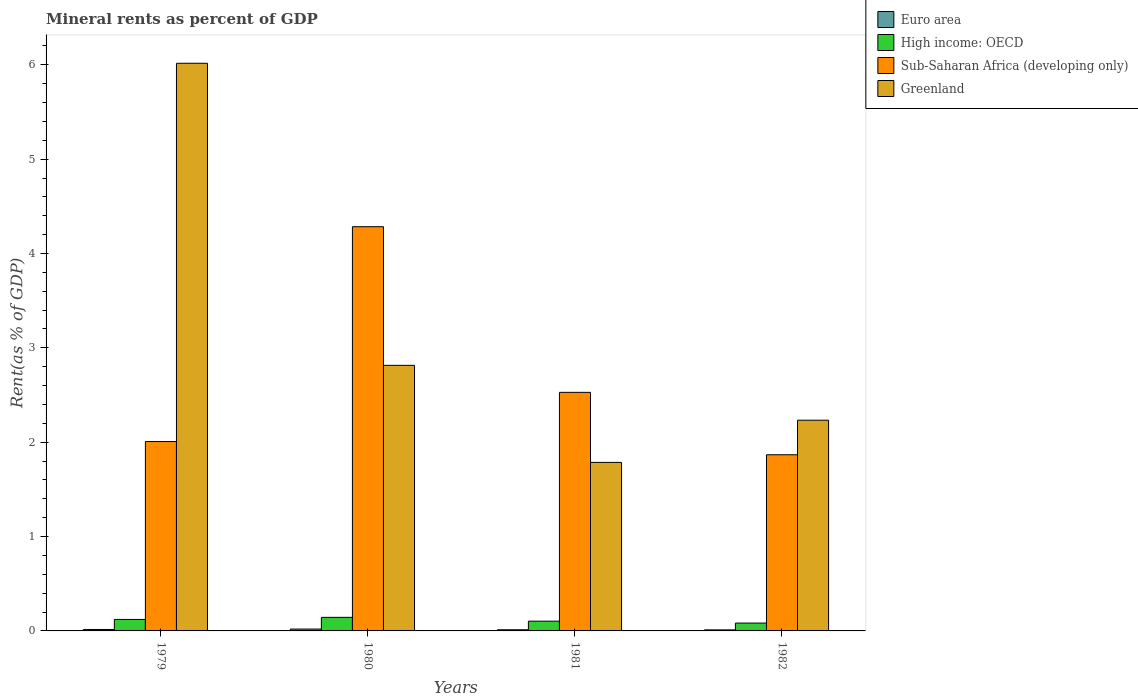How many different coloured bars are there?
Ensure brevity in your answer.  4. How many bars are there on the 1st tick from the left?
Give a very brief answer. 4. How many bars are there on the 1st tick from the right?
Your answer should be very brief. 4. What is the label of the 1st group of bars from the left?
Offer a very short reply. 1979. What is the mineral rent in Sub-Saharan Africa (developing only) in 1982?
Your response must be concise. 1.87. Across all years, what is the maximum mineral rent in Euro area?
Provide a succinct answer. 0.02. Across all years, what is the minimum mineral rent in Greenland?
Your response must be concise. 1.79. In which year was the mineral rent in Euro area minimum?
Your answer should be compact. 1982. What is the total mineral rent in Greenland in the graph?
Offer a very short reply. 12.85. What is the difference between the mineral rent in Greenland in 1979 and that in 1982?
Offer a terse response. 3.78. What is the difference between the mineral rent in Sub-Saharan Africa (developing only) in 1982 and the mineral rent in Euro area in 1980?
Your answer should be very brief. 1.85. What is the average mineral rent in Sub-Saharan Africa (developing only) per year?
Your response must be concise. 2.67. In the year 1980, what is the difference between the mineral rent in Euro area and mineral rent in Greenland?
Ensure brevity in your answer.  -2.8. What is the ratio of the mineral rent in High income: OECD in 1980 to that in 1981?
Your response must be concise. 1.39. Is the difference between the mineral rent in Euro area in 1979 and 1982 greater than the difference between the mineral rent in Greenland in 1979 and 1982?
Ensure brevity in your answer.  No. What is the difference between the highest and the second highest mineral rent in Euro area?
Offer a terse response. 0. What is the difference between the highest and the lowest mineral rent in Euro area?
Give a very brief answer. 0.01. In how many years, is the mineral rent in High income: OECD greater than the average mineral rent in High income: OECD taken over all years?
Your answer should be compact. 2. Is it the case that in every year, the sum of the mineral rent in Euro area and mineral rent in Sub-Saharan Africa (developing only) is greater than the sum of mineral rent in High income: OECD and mineral rent in Greenland?
Provide a short and direct response. No. What does the 3rd bar from the left in 1980 represents?
Give a very brief answer. Sub-Saharan Africa (developing only). What does the 1st bar from the right in 1981 represents?
Keep it short and to the point. Greenland. How many bars are there?
Your response must be concise. 16. How many years are there in the graph?
Offer a very short reply. 4. What is the difference between two consecutive major ticks on the Y-axis?
Make the answer very short. 1. Are the values on the major ticks of Y-axis written in scientific E-notation?
Your answer should be compact. No. Does the graph contain any zero values?
Your response must be concise. No. Does the graph contain grids?
Your answer should be compact. No. Where does the legend appear in the graph?
Ensure brevity in your answer.  Top right. How many legend labels are there?
Offer a terse response. 4. What is the title of the graph?
Your answer should be very brief. Mineral rents as percent of GDP. Does "Antigua and Barbuda" appear as one of the legend labels in the graph?
Offer a terse response. No. What is the label or title of the X-axis?
Your response must be concise. Years. What is the label or title of the Y-axis?
Keep it short and to the point. Rent(as % of GDP). What is the Rent(as % of GDP) of Euro area in 1979?
Your answer should be very brief. 0.02. What is the Rent(as % of GDP) in High income: OECD in 1979?
Ensure brevity in your answer.  0.12. What is the Rent(as % of GDP) of Sub-Saharan Africa (developing only) in 1979?
Your response must be concise. 2.01. What is the Rent(as % of GDP) of Greenland in 1979?
Offer a terse response. 6.02. What is the Rent(as % of GDP) of Euro area in 1980?
Your answer should be very brief. 0.02. What is the Rent(as % of GDP) in High income: OECD in 1980?
Ensure brevity in your answer.  0.14. What is the Rent(as % of GDP) in Sub-Saharan Africa (developing only) in 1980?
Provide a short and direct response. 4.28. What is the Rent(as % of GDP) of Greenland in 1980?
Offer a terse response. 2.81. What is the Rent(as % of GDP) of Euro area in 1981?
Offer a terse response. 0.01. What is the Rent(as % of GDP) of High income: OECD in 1981?
Provide a short and direct response. 0.1. What is the Rent(as % of GDP) of Sub-Saharan Africa (developing only) in 1981?
Your response must be concise. 2.53. What is the Rent(as % of GDP) of Greenland in 1981?
Make the answer very short. 1.79. What is the Rent(as % of GDP) in Euro area in 1982?
Offer a terse response. 0.01. What is the Rent(as % of GDP) in High income: OECD in 1982?
Keep it short and to the point. 0.08. What is the Rent(as % of GDP) of Sub-Saharan Africa (developing only) in 1982?
Your answer should be compact. 1.87. What is the Rent(as % of GDP) of Greenland in 1982?
Your answer should be very brief. 2.23. Across all years, what is the maximum Rent(as % of GDP) in Euro area?
Make the answer very short. 0.02. Across all years, what is the maximum Rent(as % of GDP) in High income: OECD?
Your answer should be compact. 0.14. Across all years, what is the maximum Rent(as % of GDP) of Sub-Saharan Africa (developing only)?
Offer a terse response. 4.28. Across all years, what is the maximum Rent(as % of GDP) in Greenland?
Provide a short and direct response. 6.02. Across all years, what is the minimum Rent(as % of GDP) in Euro area?
Provide a short and direct response. 0.01. Across all years, what is the minimum Rent(as % of GDP) in High income: OECD?
Provide a succinct answer. 0.08. Across all years, what is the minimum Rent(as % of GDP) in Sub-Saharan Africa (developing only)?
Offer a very short reply. 1.87. Across all years, what is the minimum Rent(as % of GDP) in Greenland?
Keep it short and to the point. 1.79. What is the total Rent(as % of GDP) of Euro area in the graph?
Your answer should be very brief. 0.06. What is the total Rent(as % of GDP) of High income: OECD in the graph?
Give a very brief answer. 0.45. What is the total Rent(as % of GDP) of Sub-Saharan Africa (developing only) in the graph?
Your answer should be very brief. 10.69. What is the total Rent(as % of GDP) in Greenland in the graph?
Your response must be concise. 12.85. What is the difference between the Rent(as % of GDP) in Euro area in 1979 and that in 1980?
Provide a short and direct response. -0. What is the difference between the Rent(as % of GDP) in High income: OECD in 1979 and that in 1980?
Your answer should be compact. -0.02. What is the difference between the Rent(as % of GDP) in Sub-Saharan Africa (developing only) in 1979 and that in 1980?
Provide a short and direct response. -2.28. What is the difference between the Rent(as % of GDP) in Greenland in 1979 and that in 1980?
Your response must be concise. 3.2. What is the difference between the Rent(as % of GDP) of Euro area in 1979 and that in 1981?
Make the answer very short. 0. What is the difference between the Rent(as % of GDP) of High income: OECD in 1979 and that in 1981?
Your response must be concise. 0.02. What is the difference between the Rent(as % of GDP) of Sub-Saharan Africa (developing only) in 1979 and that in 1981?
Make the answer very short. -0.52. What is the difference between the Rent(as % of GDP) in Greenland in 1979 and that in 1981?
Keep it short and to the point. 4.23. What is the difference between the Rent(as % of GDP) in Euro area in 1979 and that in 1982?
Ensure brevity in your answer.  0. What is the difference between the Rent(as % of GDP) in High income: OECD in 1979 and that in 1982?
Offer a very short reply. 0.04. What is the difference between the Rent(as % of GDP) in Sub-Saharan Africa (developing only) in 1979 and that in 1982?
Offer a terse response. 0.14. What is the difference between the Rent(as % of GDP) of Greenland in 1979 and that in 1982?
Provide a succinct answer. 3.78. What is the difference between the Rent(as % of GDP) in Euro area in 1980 and that in 1981?
Keep it short and to the point. 0.01. What is the difference between the Rent(as % of GDP) in High income: OECD in 1980 and that in 1981?
Make the answer very short. 0.04. What is the difference between the Rent(as % of GDP) of Sub-Saharan Africa (developing only) in 1980 and that in 1981?
Make the answer very short. 1.76. What is the difference between the Rent(as % of GDP) of Greenland in 1980 and that in 1981?
Your answer should be very brief. 1.03. What is the difference between the Rent(as % of GDP) in Euro area in 1980 and that in 1982?
Provide a succinct answer. 0.01. What is the difference between the Rent(as % of GDP) in High income: OECD in 1980 and that in 1982?
Your answer should be compact. 0.06. What is the difference between the Rent(as % of GDP) of Sub-Saharan Africa (developing only) in 1980 and that in 1982?
Your answer should be compact. 2.42. What is the difference between the Rent(as % of GDP) of Greenland in 1980 and that in 1982?
Provide a short and direct response. 0.58. What is the difference between the Rent(as % of GDP) of Euro area in 1981 and that in 1982?
Your answer should be very brief. 0. What is the difference between the Rent(as % of GDP) of High income: OECD in 1981 and that in 1982?
Offer a very short reply. 0.02. What is the difference between the Rent(as % of GDP) in Sub-Saharan Africa (developing only) in 1981 and that in 1982?
Your response must be concise. 0.66. What is the difference between the Rent(as % of GDP) in Greenland in 1981 and that in 1982?
Your answer should be very brief. -0.45. What is the difference between the Rent(as % of GDP) in Euro area in 1979 and the Rent(as % of GDP) in High income: OECD in 1980?
Provide a short and direct response. -0.13. What is the difference between the Rent(as % of GDP) of Euro area in 1979 and the Rent(as % of GDP) of Sub-Saharan Africa (developing only) in 1980?
Your answer should be very brief. -4.27. What is the difference between the Rent(as % of GDP) of Euro area in 1979 and the Rent(as % of GDP) of Greenland in 1980?
Ensure brevity in your answer.  -2.8. What is the difference between the Rent(as % of GDP) of High income: OECD in 1979 and the Rent(as % of GDP) of Sub-Saharan Africa (developing only) in 1980?
Your answer should be very brief. -4.16. What is the difference between the Rent(as % of GDP) of High income: OECD in 1979 and the Rent(as % of GDP) of Greenland in 1980?
Your answer should be very brief. -2.69. What is the difference between the Rent(as % of GDP) in Sub-Saharan Africa (developing only) in 1979 and the Rent(as % of GDP) in Greenland in 1980?
Your response must be concise. -0.81. What is the difference between the Rent(as % of GDP) in Euro area in 1979 and the Rent(as % of GDP) in High income: OECD in 1981?
Provide a short and direct response. -0.09. What is the difference between the Rent(as % of GDP) of Euro area in 1979 and the Rent(as % of GDP) of Sub-Saharan Africa (developing only) in 1981?
Provide a succinct answer. -2.51. What is the difference between the Rent(as % of GDP) in Euro area in 1979 and the Rent(as % of GDP) in Greenland in 1981?
Offer a terse response. -1.77. What is the difference between the Rent(as % of GDP) of High income: OECD in 1979 and the Rent(as % of GDP) of Sub-Saharan Africa (developing only) in 1981?
Make the answer very short. -2.41. What is the difference between the Rent(as % of GDP) in High income: OECD in 1979 and the Rent(as % of GDP) in Greenland in 1981?
Your answer should be compact. -1.66. What is the difference between the Rent(as % of GDP) of Sub-Saharan Africa (developing only) in 1979 and the Rent(as % of GDP) of Greenland in 1981?
Your response must be concise. 0.22. What is the difference between the Rent(as % of GDP) of Euro area in 1979 and the Rent(as % of GDP) of High income: OECD in 1982?
Make the answer very short. -0.07. What is the difference between the Rent(as % of GDP) in Euro area in 1979 and the Rent(as % of GDP) in Sub-Saharan Africa (developing only) in 1982?
Provide a short and direct response. -1.85. What is the difference between the Rent(as % of GDP) of Euro area in 1979 and the Rent(as % of GDP) of Greenland in 1982?
Offer a very short reply. -2.22. What is the difference between the Rent(as % of GDP) in High income: OECD in 1979 and the Rent(as % of GDP) in Sub-Saharan Africa (developing only) in 1982?
Provide a short and direct response. -1.75. What is the difference between the Rent(as % of GDP) of High income: OECD in 1979 and the Rent(as % of GDP) of Greenland in 1982?
Offer a terse response. -2.11. What is the difference between the Rent(as % of GDP) of Sub-Saharan Africa (developing only) in 1979 and the Rent(as % of GDP) of Greenland in 1982?
Offer a very short reply. -0.23. What is the difference between the Rent(as % of GDP) of Euro area in 1980 and the Rent(as % of GDP) of High income: OECD in 1981?
Ensure brevity in your answer.  -0.08. What is the difference between the Rent(as % of GDP) in Euro area in 1980 and the Rent(as % of GDP) in Sub-Saharan Africa (developing only) in 1981?
Make the answer very short. -2.51. What is the difference between the Rent(as % of GDP) in Euro area in 1980 and the Rent(as % of GDP) in Greenland in 1981?
Make the answer very short. -1.77. What is the difference between the Rent(as % of GDP) of High income: OECD in 1980 and the Rent(as % of GDP) of Sub-Saharan Africa (developing only) in 1981?
Provide a short and direct response. -2.38. What is the difference between the Rent(as % of GDP) in High income: OECD in 1980 and the Rent(as % of GDP) in Greenland in 1981?
Your answer should be compact. -1.64. What is the difference between the Rent(as % of GDP) in Sub-Saharan Africa (developing only) in 1980 and the Rent(as % of GDP) in Greenland in 1981?
Your response must be concise. 2.5. What is the difference between the Rent(as % of GDP) of Euro area in 1980 and the Rent(as % of GDP) of High income: OECD in 1982?
Offer a very short reply. -0.06. What is the difference between the Rent(as % of GDP) of Euro area in 1980 and the Rent(as % of GDP) of Sub-Saharan Africa (developing only) in 1982?
Ensure brevity in your answer.  -1.85. What is the difference between the Rent(as % of GDP) in Euro area in 1980 and the Rent(as % of GDP) in Greenland in 1982?
Offer a terse response. -2.21. What is the difference between the Rent(as % of GDP) in High income: OECD in 1980 and the Rent(as % of GDP) in Sub-Saharan Africa (developing only) in 1982?
Give a very brief answer. -1.72. What is the difference between the Rent(as % of GDP) of High income: OECD in 1980 and the Rent(as % of GDP) of Greenland in 1982?
Give a very brief answer. -2.09. What is the difference between the Rent(as % of GDP) of Sub-Saharan Africa (developing only) in 1980 and the Rent(as % of GDP) of Greenland in 1982?
Give a very brief answer. 2.05. What is the difference between the Rent(as % of GDP) in Euro area in 1981 and the Rent(as % of GDP) in High income: OECD in 1982?
Give a very brief answer. -0.07. What is the difference between the Rent(as % of GDP) in Euro area in 1981 and the Rent(as % of GDP) in Sub-Saharan Africa (developing only) in 1982?
Provide a short and direct response. -1.85. What is the difference between the Rent(as % of GDP) in Euro area in 1981 and the Rent(as % of GDP) in Greenland in 1982?
Your answer should be compact. -2.22. What is the difference between the Rent(as % of GDP) in High income: OECD in 1981 and the Rent(as % of GDP) in Sub-Saharan Africa (developing only) in 1982?
Provide a short and direct response. -1.76. What is the difference between the Rent(as % of GDP) in High income: OECD in 1981 and the Rent(as % of GDP) in Greenland in 1982?
Your answer should be compact. -2.13. What is the difference between the Rent(as % of GDP) of Sub-Saharan Africa (developing only) in 1981 and the Rent(as % of GDP) of Greenland in 1982?
Ensure brevity in your answer.  0.3. What is the average Rent(as % of GDP) in Euro area per year?
Provide a succinct answer. 0.01. What is the average Rent(as % of GDP) in High income: OECD per year?
Keep it short and to the point. 0.11. What is the average Rent(as % of GDP) in Sub-Saharan Africa (developing only) per year?
Your answer should be compact. 2.67. What is the average Rent(as % of GDP) of Greenland per year?
Provide a succinct answer. 3.21. In the year 1979, what is the difference between the Rent(as % of GDP) in Euro area and Rent(as % of GDP) in High income: OECD?
Your answer should be very brief. -0.11. In the year 1979, what is the difference between the Rent(as % of GDP) in Euro area and Rent(as % of GDP) in Sub-Saharan Africa (developing only)?
Keep it short and to the point. -1.99. In the year 1979, what is the difference between the Rent(as % of GDP) in Euro area and Rent(as % of GDP) in Greenland?
Make the answer very short. -6. In the year 1979, what is the difference between the Rent(as % of GDP) in High income: OECD and Rent(as % of GDP) in Sub-Saharan Africa (developing only)?
Provide a succinct answer. -1.89. In the year 1979, what is the difference between the Rent(as % of GDP) of High income: OECD and Rent(as % of GDP) of Greenland?
Your answer should be very brief. -5.89. In the year 1979, what is the difference between the Rent(as % of GDP) of Sub-Saharan Africa (developing only) and Rent(as % of GDP) of Greenland?
Your answer should be very brief. -4.01. In the year 1980, what is the difference between the Rent(as % of GDP) of Euro area and Rent(as % of GDP) of High income: OECD?
Provide a succinct answer. -0.12. In the year 1980, what is the difference between the Rent(as % of GDP) in Euro area and Rent(as % of GDP) in Sub-Saharan Africa (developing only)?
Ensure brevity in your answer.  -4.26. In the year 1980, what is the difference between the Rent(as % of GDP) of Euro area and Rent(as % of GDP) of Greenland?
Ensure brevity in your answer.  -2.79. In the year 1980, what is the difference between the Rent(as % of GDP) in High income: OECD and Rent(as % of GDP) in Sub-Saharan Africa (developing only)?
Offer a very short reply. -4.14. In the year 1980, what is the difference between the Rent(as % of GDP) in High income: OECD and Rent(as % of GDP) in Greenland?
Provide a succinct answer. -2.67. In the year 1980, what is the difference between the Rent(as % of GDP) in Sub-Saharan Africa (developing only) and Rent(as % of GDP) in Greenland?
Offer a terse response. 1.47. In the year 1981, what is the difference between the Rent(as % of GDP) in Euro area and Rent(as % of GDP) in High income: OECD?
Your answer should be very brief. -0.09. In the year 1981, what is the difference between the Rent(as % of GDP) of Euro area and Rent(as % of GDP) of Sub-Saharan Africa (developing only)?
Offer a very short reply. -2.52. In the year 1981, what is the difference between the Rent(as % of GDP) of Euro area and Rent(as % of GDP) of Greenland?
Your answer should be very brief. -1.77. In the year 1981, what is the difference between the Rent(as % of GDP) in High income: OECD and Rent(as % of GDP) in Sub-Saharan Africa (developing only)?
Offer a terse response. -2.43. In the year 1981, what is the difference between the Rent(as % of GDP) in High income: OECD and Rent(as % of GDP) in Greenland?
Your response must be concise. -1.68. In the year 1981, what is the difference between the Rent(as % of GDP) in Sub-Saharan Africa (developing only) and Rent(as % of GDP) in Greenland?
Offer a very short reply. 0.74. In the year 1982, what is the difference between the Rent(as % of GDP) of Euro area and Rent(as % of GDP) of High income: OECD?
Provide a succinct answer. -0.07. In the year 1982, what is the difference between the Rent(as % of GDP) of Euro area and Rent(as % of GDP) of Sub-Saharan Africa (developing only)?
Your answer should be compact. -1.86. In the year 1982, what is the difference between the Rent(as % of GDP) of Euro area and Rent(as % of GDP) of Greenland?
Offer a terse response. -2.22. In the year 1982, what is the difference between the Rent(as % of GDP) in High income: OECD and Rent(as % of GDP) in Sub-Saharan Africa (developing only)?
Your answer should be compact. -1.78. In the year 1982, what is the difference between the Rent(as % of GDP) in High income: OECD and Rent(as % of GDP) in Greenland?
Give a very brief answer. -2.15. In the year 1982, what is the difference between the Rent(as % of GDP) of Sub-Saharan Africa (developing only) and Rent(as % of GDP) of Greenland?
Your answer should be compact. -0.37. What is the ratio of the Rent(as % of GDP) of Euro area in 1979 to that in 1980?
Provide a succinct answer. 0.78. What is the ratio of the Rent(as % of GDP) of High income: OECD in 1979 to that in 1980?
Your response must be concise. 0.85. What is the ratio of the Rent(as % of GDP) in Sub-Saharan Africa (developing only) in 1979 to that in 1980?
Keep it short and to the point. 0.47. What is the ratio of the Rent(as % of GDP) of Greenland in 1979 to that in 1980?
Provide a succinct answer. 2.14. What is the ratio of the Rent(as % of GDP) in Euro area in 1979 to that in 1981?
Keep it short and to the point. 1.25. What is the ratio of the Rent(as % of GDP) of High income: OECD in 1979 to that in 1981?
Ensure brevity in your answer.  1.18. What is the ratio of the Rent(as % of GDP) in Sub-Saharan Africa (developing only) in 1979 to that in 1981?
Your answer should be compact. 0.79. What is the ratio of the Rent(as % of GDP) in Greenland in 1979 to that in 1981?
Make the answer very short. 3.37. What is the ratio of the Rent(as % of GDP) of Euro area in 1979 to that in 1982?
Offer a terse response. 1.38. What is the ratio of the Rent(as % of GDP) in High income: OECD in 1979 to that in 1982?
Your answer should be compact. 1.46. What is the ratio of the Rent(as % of GDP) of Sub-Saharan Africa (developing only) in 1979 to that in 1982?
Keep it short and to the point. 1.08. What is the ratio of the Rent(as % of GDP) in Greenland in 1979 to that in 1982?
Give a very brief answer. 2.69. What is the ratio of the Rent(as % of GDP) in Euro area in 1980 to that in 1981?
Ensure brevity in your answer.  1.61. What is the ratio of the Rent(as % of GDP) in High income: OECD in 1980 to that in 1981?
Give a very brief answer. 1.39. What is the ratio of the Rent(as % of GDP) of Sub-Saharan Africa (developing only) in 1980 to that in 1981?
Your answer should be compact. 1.69. What is the ratio of the Rent(as % of GDP) of Greenland in 1980 to that in 1981?
Your answer should be very brief. 1.58. What is the ratio of the Rent(as % of GDP) of Euro area in 1980 to that in 1982?
Your answer should be compact. 1.78. What is the ratio of the Rent(as % of GDP) of High income: OECD in 1980 to that in 1982?
Make the answer very short. 1.73. What is the ratio of the Rent(as % of GDP) in Sub-Saharan Africa (developing only) in 1980 to that in 1982?
Keep it short and to the point. 2.29. What is the ratio of the Rent(as % of GDP) in Greenland in 1980 to that in 1982?
Ensure brevity in your answer.  1.26. What is the ratio of the Rent(as % of GDP) of Euro area in 1981 to that in 1982?
Offer a very short reply. 1.1. What is the ratio of the Rent(as % of GDP) in High income: OECD in 1981 to that in 1982?
Provide a short and direct response. 1.24. What is the ratio of the Rent(as % of GDP) in Sub-Saharan Africa (developing only) in 1981 to that in 1982?
Your answer should be very brief. 1.35. What is the ratio of the Rent(as % of GDP) in Greenland in 1981 to that in 1982?
Your response must be concise. 0.8. What is the difference between the highest and the second highest Rent(as % of GDP) of Euro area?
Provide a succinct answer. 0. What is the difference between the highest and the second highest Rent(as % of GDP) of High income: OECD?
Ensure brevity in your answer.  0.02. What is the difference between the highest and the second highest Rent(as % of GDP) in Sub-Saharan Africa (developing only)?
Your answer should be compact. 1.76. What is the difference between the highest and the second highest Rent(as % of GDP) of Greenland?
Offer a terse response. 3.2. What is the difference between the highest and the lowest Rent(as % of GDP) in Euro area?
Offer a terse response. 0.01. What is the difference between the highest and the lowest Rent(as % of GDP) in High income: OECD?
Ensure brevity in your answer.  0.06. What is the difference between the highest and the lowest Rent(as % of GDP) in Sub-Saharan Africa (developing only)?
Ensure brevity in your answer.  2.42. What is the difference between the highest and the lowest Rent(as % of GDP) in Greenland?
Your response must be concise. 4.23. 